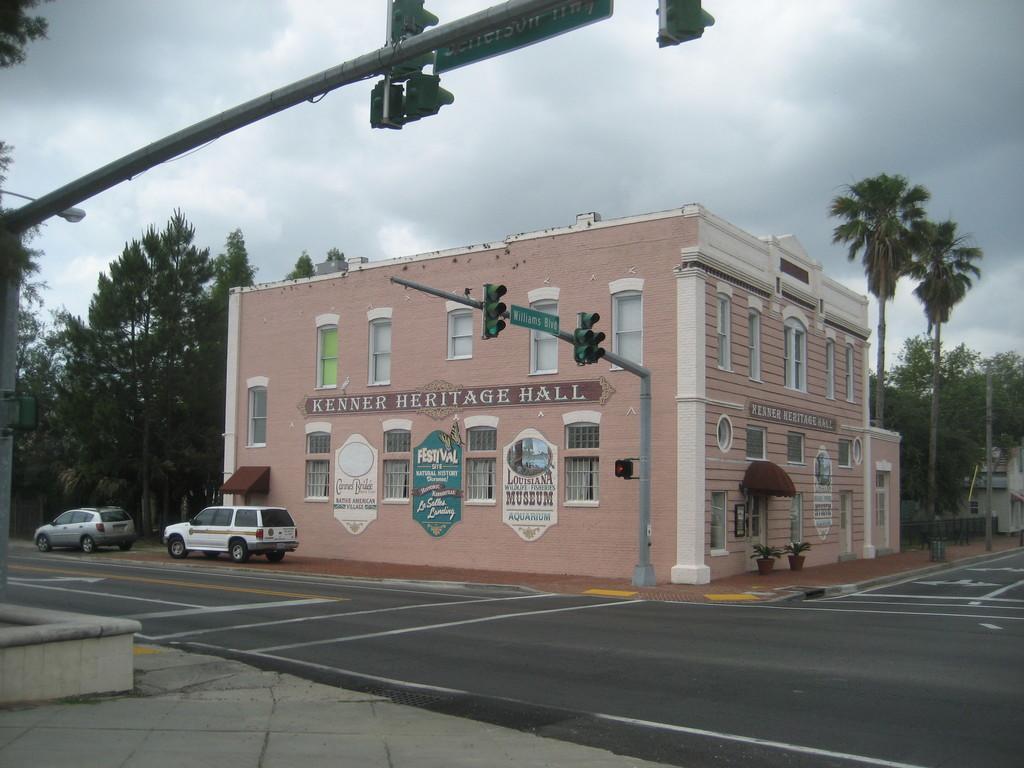In one or two sentences, can you explain what this image depicts? In this image I can see a building. At the bottom there is a road. There are few cars. In the background there are trees. At the top I can see clouds in the sky. 